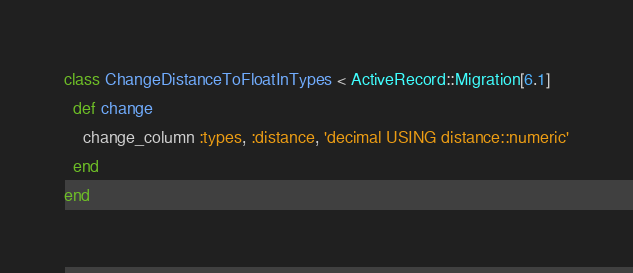<code> <loc_0><loc_0><loc_500><loc_500><_Ruby_>class ChangeDistanceToFloatInTypes < ActiveRecord::Migration[6.1]
  def change
    change_column :types, :distance, 'decimal USING distance::numeric'
  end
end
</code> 